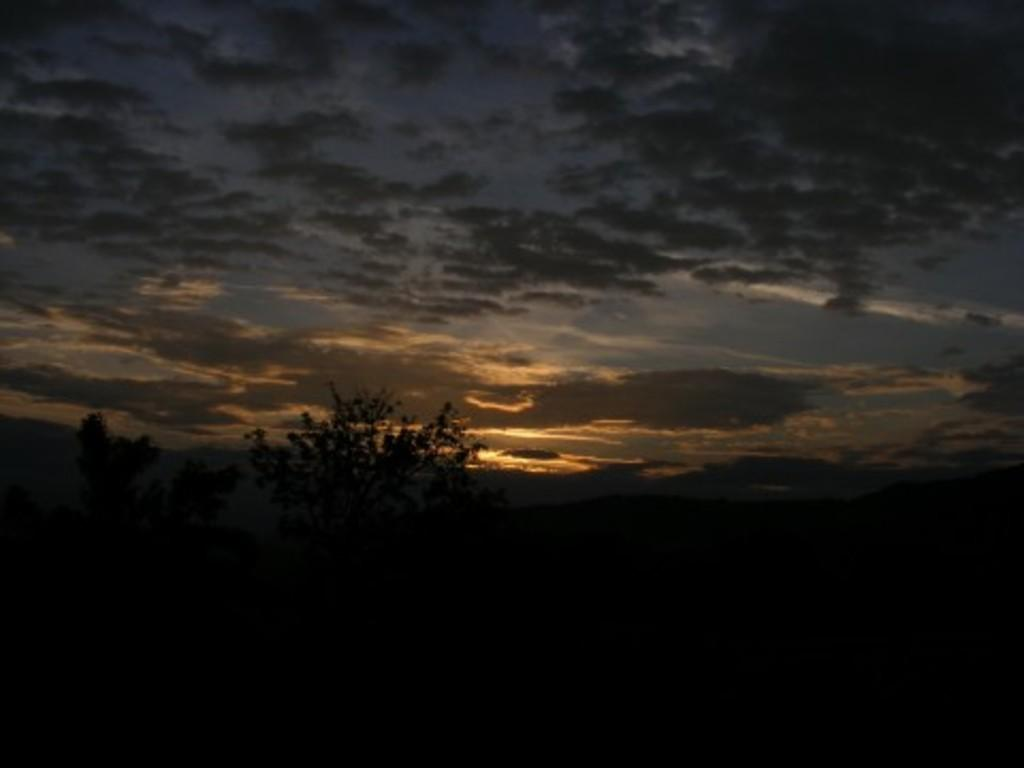What is the color or lighting condition at the bottom of the image? The bottom of the image is dark. What can be seen in the middle of the image? There are trees in the middle of the image. What is visible at the top of the image? The sky is visible at the top of the image. Can you see a yoke in the image? There is no yoke present in the image. Is there a place to sleep in the image? There is no indication of a place to sleep in the image. Is the image taken on an island? There is no information provided about the image being taken on an island. 